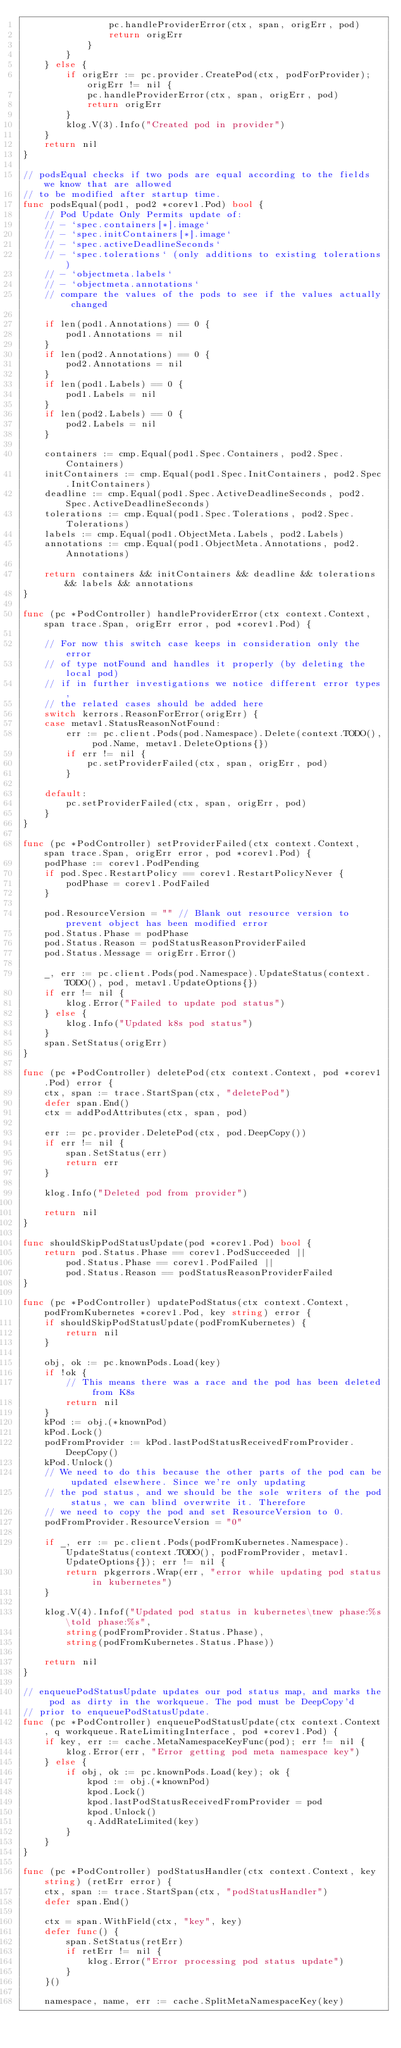Convert code to text. <code><loc_0><loc_0><loc_500><loc_500><_Go_>				pc.handleProviderError(ctx, span, origErr, pod)
				return origErr
			}
		}
	} else {
		if origErr := pc.provider.CreatePod(ctx, podForProvider); origErr != nil {
			pc.handleProviderError(ctx, span, origErr, pod)
			return origErr
		}
		klog.V(3).Info("Created pod in provider")
	}
	return nil
}

// podsEqual checks if two pods are equal according to the fields we know that are allowed
// to be modified after startup time.
func podsEqual(pod1, pod2 *corev1.Pod) bool {
	// Pod Update Only Permits update of:
	// - `spec.containers[*].image`
	// - `spec.initContainers[*].image`
	// - `spec.activeDeadlineSeconds`
	// - `spec.tolerations` (only additions to existing tolerations)
	// - `objectmeta.labels`
	// - `objectmeta.annotations`
	// compare the values of the pods to see if the values actually changed

	if len(pod1.Annotations) == 0 {
		pod1.Annotations = nil
	}
	if len(pod2.Annotations) == 0 {
		pod2.Annotations = nil
	}
	if len(pod1.Labels) == 0 {
		pod1.Labels = nil
	}
	if len(pod2.Labels) == 0 {
		pod2.Labels = nil
	}

	containers := cmp.Equal(pod1.Spec.Containers, pod2.Spec.Containers)
	initContainers := cmp.Equal(pod1.Spec.InitContainers, pod2.Spec.InitContainers)
	deadline := cmp.Equal(pod1.Spec.ActiveDeadlineSeconds, pod2.Spec.ActiveDeadlineSeconds)
	tolerations := cmp.Equal(pod1.Spec.Tolerations, pod2.Spec.Tolerations)
	labels := cmp.Equal(pod1.ObjectMeta.Labels, pod2.Labels)
	annotations := cmp.Equal(pod1.ObjectMeta.Annotations, pod2.Annotations)

	return containers && initContainers && deadline && tolerations && labels && annotations
}

func (pc *PodController) handleProviderError(ctx context.Context, span trace.Span, origErr error, pod *corev1.Pod) {

	// For now this switch case keeps in consideration only the error
	// of type notFound and handles it properly (by deleting the local pod)
	// if in further investigations we notice different error types,
	// the related cases should be added here
	switch kerrors.ReasonForError(origErr) {
	case metav1.StatusReasonNotFound:
		err := pc.client.Pods(pod.Namespace).Delete(context.TODO(), pod.Name, metav1.DeleteOptions{})
		if err != nil {
			pc.setProviderFailed(ctx, span, origErr, pod)
		}

	default:
		pc.setProviderFailed(ctx, span, origErr, pod)
	}
}

func (pc *PodController) setProviderFailed(ctx context.Context, span trace.Span, origErr error, pod *corev1.Pod) {
	podPhase := corev1.PodPending
	if pod.Spec.RestartPolicy == corev1.RestartPolicyNever {
		podPhase = corev1.PodFailed
	}

	pod.ResourceVersion = "" // Blank out resource version to prevent object has been modified error
	pod.Status.Phase = podPhase
	pod.Status.Reason = podStatusReasonProviderFailed
	pod.Status.Message = origErr.Error()

	_, err := pc.client.Pods(pod.Namespace).UpdateStatus(context.TODO(), pod, metav1.UpdateOptions{})
	if err != nil {
		klog.Error("Failed to update pod status")
	} else {
		klog.Info("Updated k8s pod status")
	}
	span.SetStatus(origErr)
}

func (pc *PodController) deletePod(ctx context.Context, pod *corev1.Pod) error {
	ctx, span := trace.StartSpan(ctx, "deletePod")
	defer span.End()
	ctx = addPodAttributes(ctx, span, pod)

	err := pc.provider.DeletePod(ctx, pod.DeepCopy())
	if err != nil {
		span.SetStatus(err)
		return err
	}

	klog.Info("Deleted pod from provider")

	return nil
}

func shouldSkipPodStatusUpdate(pod *corev1.Pod) bool {
	return pod.Status.Phase == corev1.PodSucceeded ||
		pod.Status.Phase == corev1.PodFailed ||
		pod.Status.Reason == podStatusReasonProviderFailed
}

func (pc *PodController) updatePodStatus(ctx context.Context, podFromKubernetes *corev1.Pod, key string) error {
	if shouldSkipPodStatusUpdate(podFromKubernetes) {
		return nil
	}

	obj, ok := pc.knownPods.Load(key)
	if !ok {
		// This means there was a race and the pod has been deleted from K8s
		return nil
	}
	kPod := obj.(*knownPod)
	kPod.Lock()
	podFromProvider := kPod.lastPodStatusReceivedFromProvider.DeepCopy()
	kPod.Unlock()
	// We need to do this because the other parts of the pod can be updated elsewhere. Since we're only updating
	// the pod status, and we should be the sole writers of the pod status, we can blind overwrite it. Therefore
	// we need to copy the pod and set ResourceVersion to 0.
	podFromProvider.ResourceVersion = "0"

	if _, err := pc.client.Pods(podFromKubernetes.Namespace).UpdateStatus(context.TODO(), podFromProvider, metav1.UpdateOptions{}); err != nil {
		return pkgerrors.Wrap(err, "error while updating pod status in kubernetes")
	}

	klog.V(4).Infof("Updated pod status in kubernetes\tnew phase:%s\told phase:%s",
		string(podFromProvider.Status.Phase),
		string(podFromKubernetes.Status.Phase))

	return nil
}

// enqueuePodStatusUpdate updates our pod status map, and marks the pod as dirty in the workqueue. The pod must be DeepCopy'd
// prior to enqueuePodStatusUpdate.
func (pc *PodController) enqueuePodStatusUpdate(ctx context.Context, q workqueue.RateLimitingInterface, pod *corev1.Pod) {
	if key, err := cache.MetaNamespaceKeyFunc(pod); err != nil {
		klog.Error(err, "Error getting pod meta namespace key")
	} else {
		if obj, ok := pc.knownPods.Load(key); ok {
			kpod := obj.(*knownPod)
			kpod.Lock()
			kpod.lastPodStatusReceivedFromProvider = pod
			kpod.Unlock()
			q.AddRateLimited(key)
		}
	}
}

func (pc *PodController) podStatusHandler(ctx context.Context, key string) (retErr error) {
	ctx, span := trace.StartSpan(ctx, "podStatusHandler")
	defer span.End()

	ctx = span.WithField(ctx, "key", key)
	defer func() {
		span.SetStatus(retErr)
		if retErr != nil {
			klog.Error("Error processing pod status update")
		}
	}()

	namespace, name, err := cache.SplitMetaNamespaceKey(key)</code> 